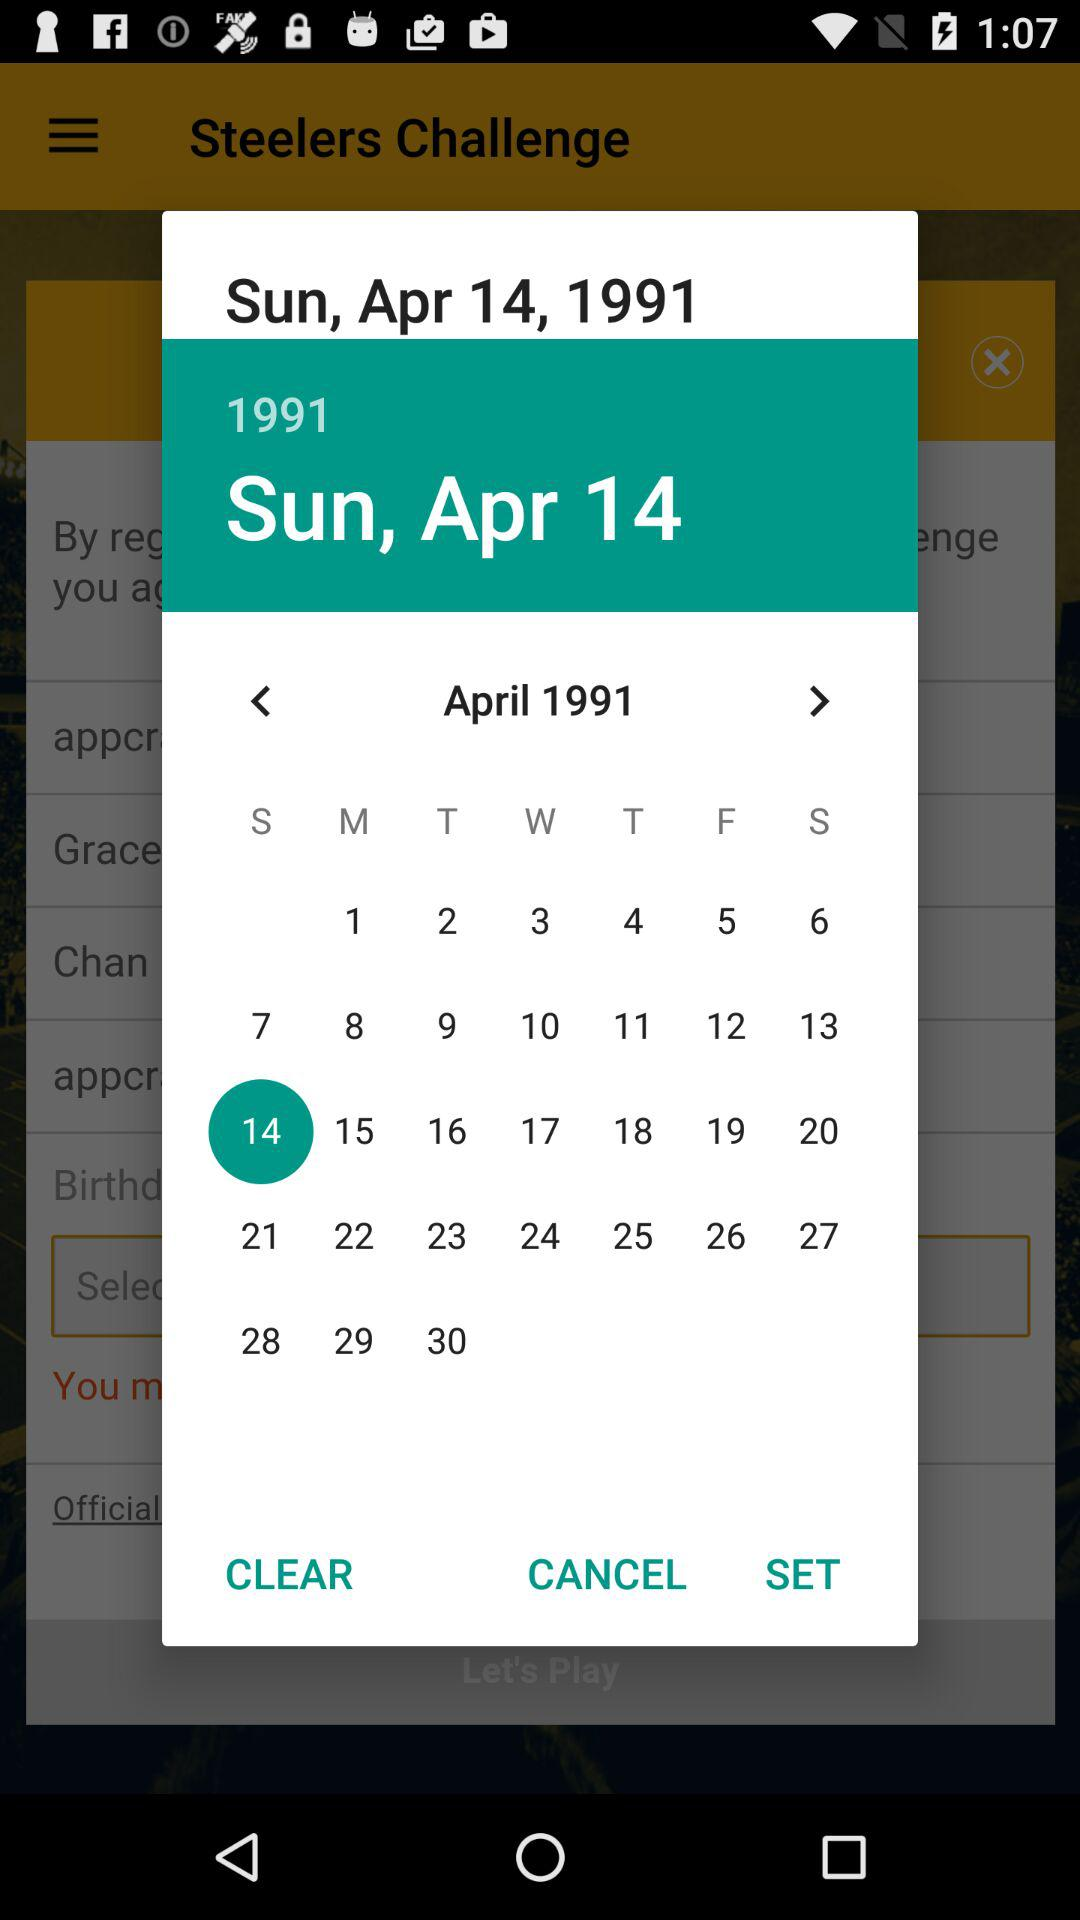What is the month and year? The month and year are April and 1991. 